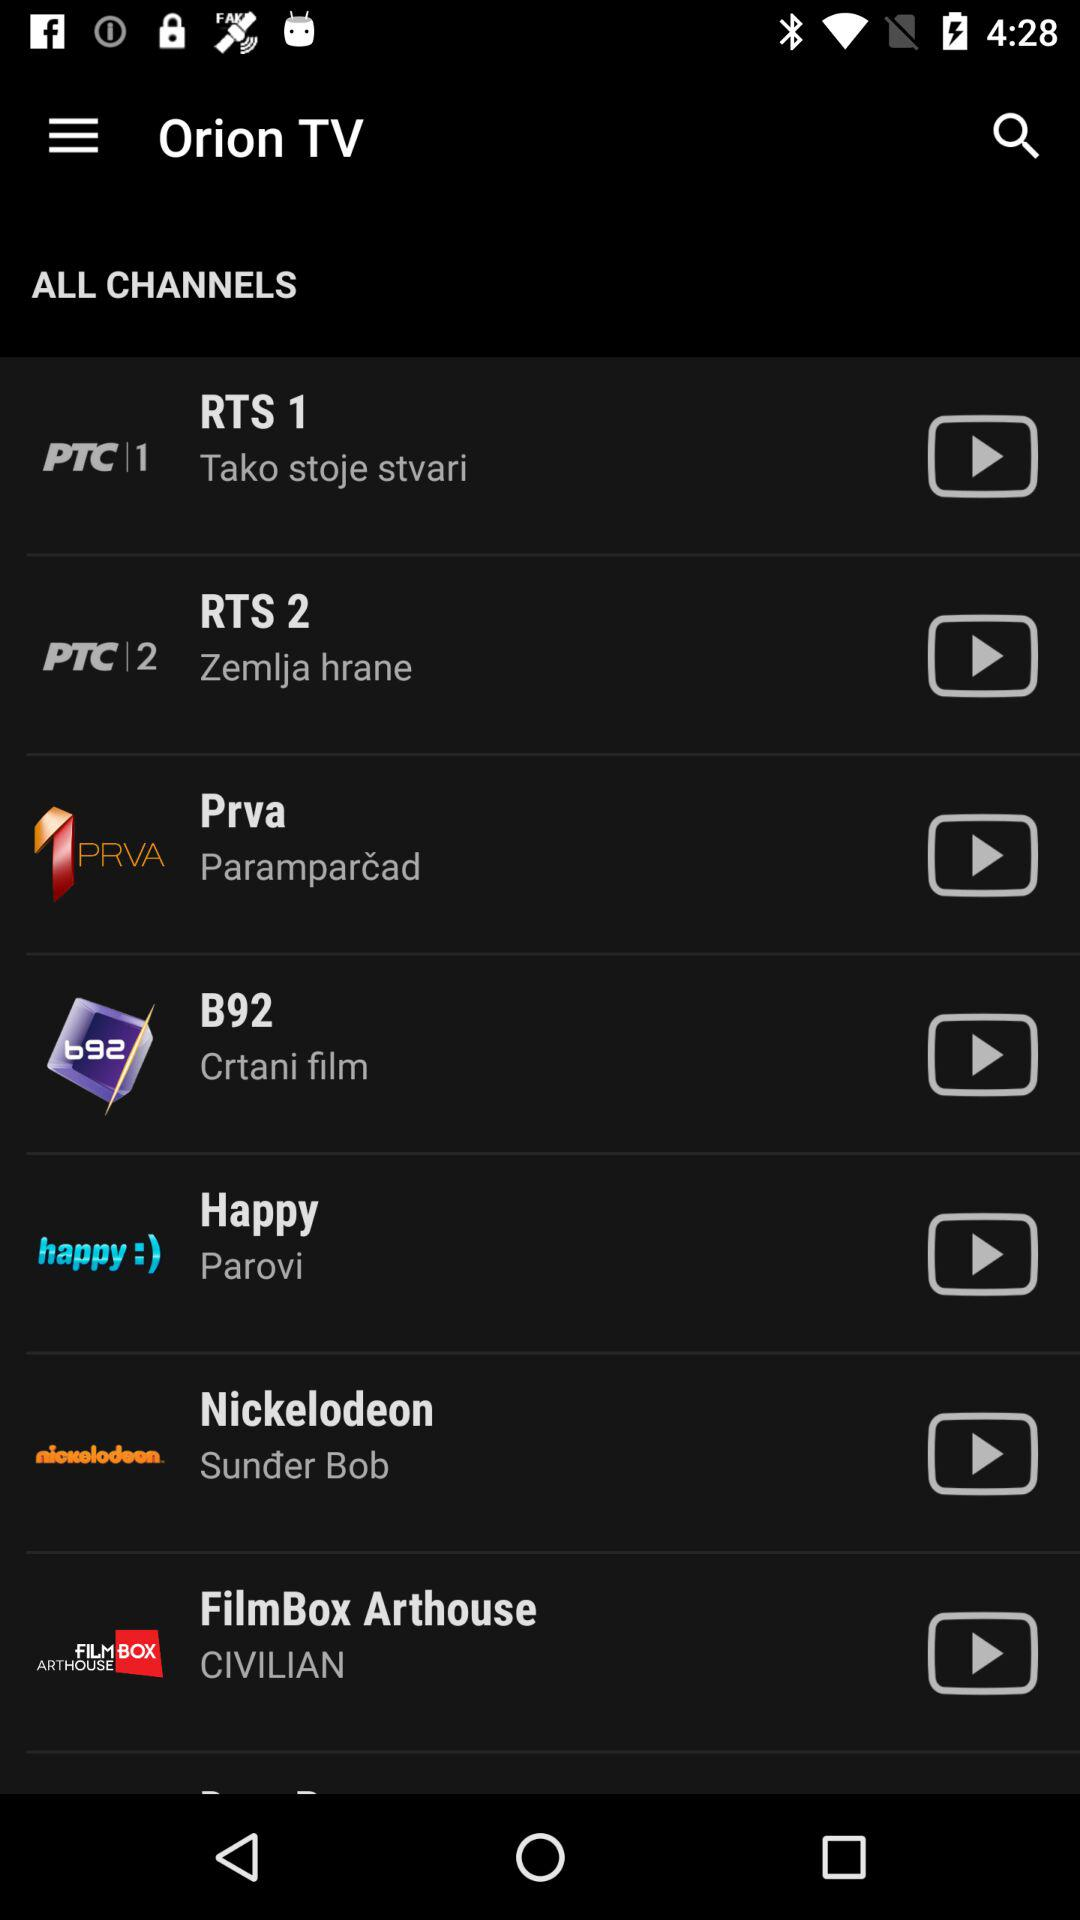What is the application name? The application name is "Orion TV". 